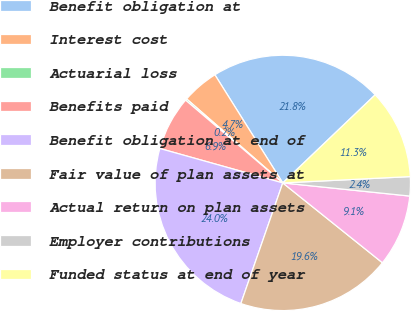<chart> <loc_0><loc_0><loc_500><loc_500><pie_chart><fcel>Benefit obligation at<fcel>Interest cost<fcel>Actuarial loss<fcel>Benefits paid<fcel>Benefit obligation at end of<fcel>Fair value of plan assets at<fcel>Actual return on plan assets<fcel>Employer contributions<fcel>Funded status at end of year<nl><fcel>21.8%<fcel>4.65%<fcel>0.2%<fcel>6.88%<fcel>24.02%<fcel>19.57%<fcel>9.11%<fcel>2.43%<fcel>11.33%<nl></chart> 